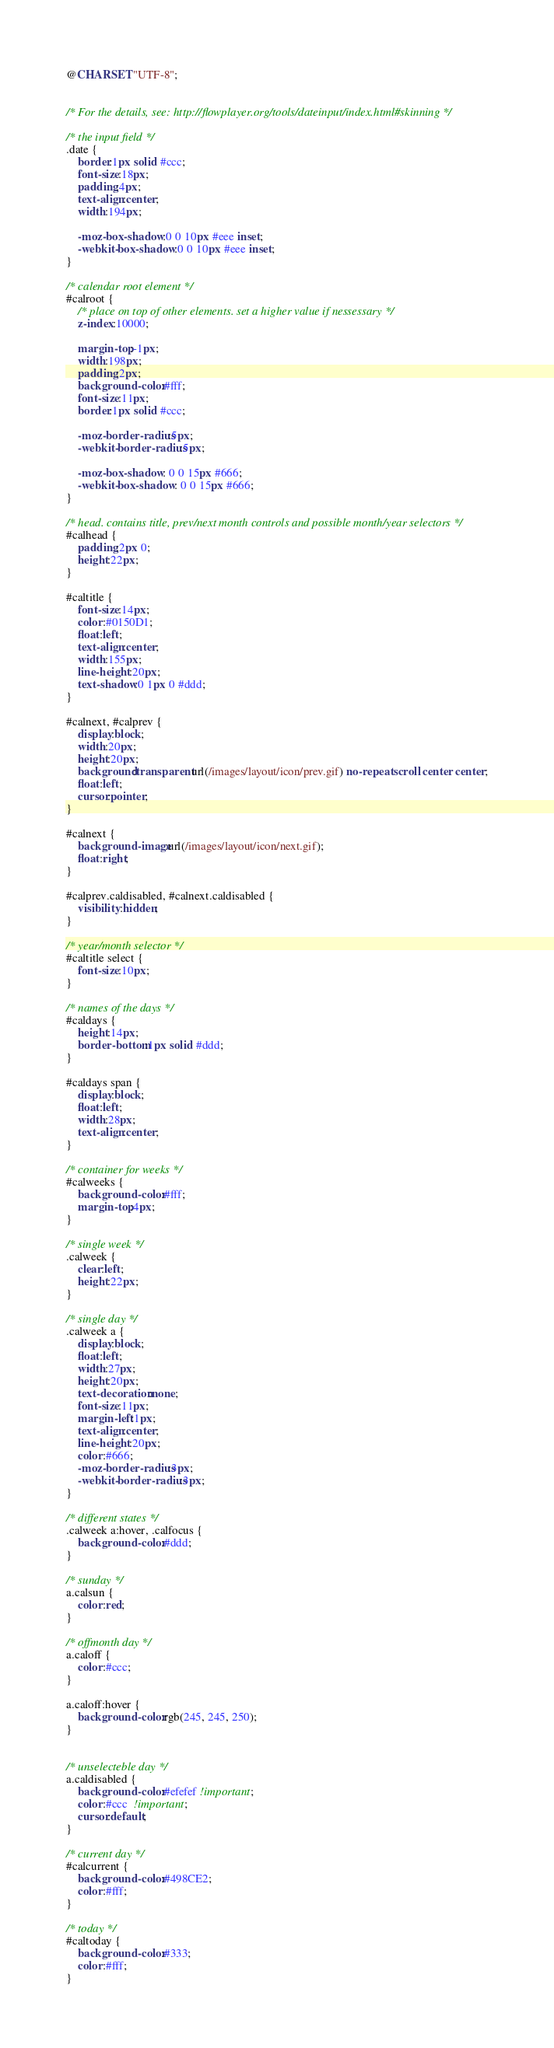Convert code to text. <code><loc_0><loc_0><loc_500><loc_500><_CSS_>@CHARSET "UTF-8";


/* For the details, see: http://flowplayer.org/tools/dateinput/index.html#skinning */

/* the input field */
.date {
    border:1px solid #ccc;
    font-size:18px;
    padding:4px;
    text-align:center;
    width:194px;
    
    -moz-box-shadow:0 0 10px #eee inset;
    -webkit-box-shadow:0 0 10px #eee inset;
}

/* calendar root element */
#calroot {
    /* place on top of other elements. set a higher value if nessessary */
    z-index:10000;
    
    margin-top:-1px;
    width:198px;
    padding:2px;
    background-color:#fff;
    font-size:11px;
    border:1px solid #ccc;
    
    -moz-border-radius:5px;
    -webkit-border-radius:5px;
    
    -moz-box-shadow: 0 0 15px #666;
    -webkit-box-shadow: 0 0 15px #666;  
}

/* head. contains title, prev/next month controls and possible month/year selectors */
#calhead {  
    padding:2px 0;
    height:22px;
} 

#caltitle {
    font-size:14px;
    color:#0150D1;  
    float:left;
    text-align:center;
    width:155px;
    line-height:20px;
    text-shadow:0 1px 0 #ddd;
}

#calnext, #calprev {
    display:block;
    width:20px;
    height:20px;
    background:transparent url(/images/layout/icon/prev.gif) no-repeat scroll center center;
    float:left;
    cursor:pointer;
}

#calnext {
    background-image:url(/images/layout/icon/next.gif);
    float:right;
}

#calprev.caldisabled, #calnext.caldisabled {
    visibility:hidden;  
}

/* year/month selector */
#caltitle select {
    font-size:10px; 
}

/* names of the days */
#caldays {
    height:14px;
    border-bottom:1px solid #ddd;
}

#caldays span {
    display:block;
    float:left;
    width:28px;
    text-align:center;
}

/* container for weeks */
#calweeks {
    background-color:#fff;
    margin-top:4px;
}

/* single week */
.calweek {
    clear:left;
    height:22px;
}

/* single day */
.calweek a {
    display:block;
    float:left;
    width:27px;
    height:20px;
    text-decoration:none;
    font-size:11px;
    margin-left:1px;
    text-align:center;
    line-height:20px;
    color:#666;
    -moz-border-radius:3px;
    -webkit-border-radius:3px;      
} 

/* different states */
.calweek a:hover, .calfocus {
    background-color:#ddd;
}

/* sunday */
a.calsun {
    color:red;      
}

/* offmonth day */
a.caloff {
    color:#ccc;     
}

a.caloff:hover {
    background-color:rgb(245, 245, 250);        
}


/* unselecteble day */
a.caldisabled {
    background-color:#efefef !important;
    color:#ccc  !important;
    cursor:default;
}

/* current day */
#calcurrent {
    background-color:#498CE2;
    color:#fff;
}

/* today */
#caltoday {
    background-color:#333;
    color:#fff;
}</code> 